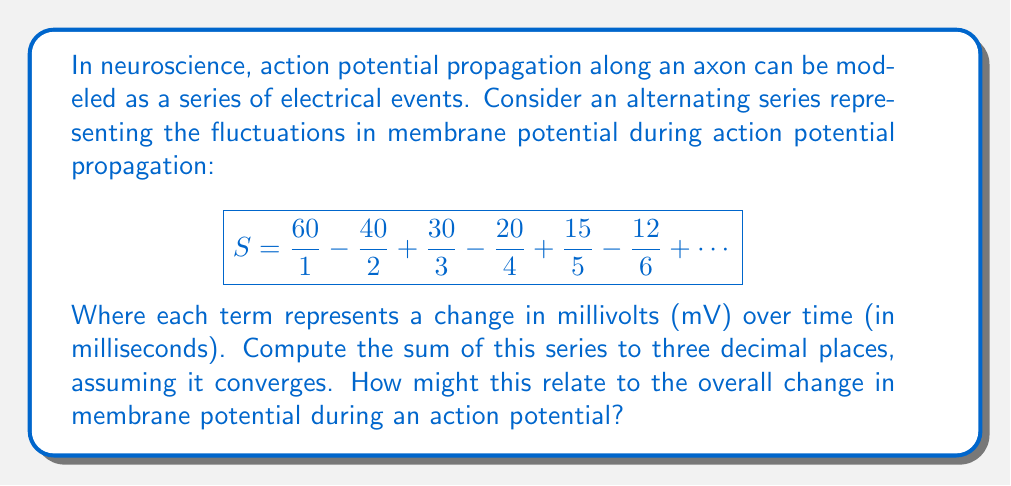What is the answer to this math problem? To solve this problem, we'll use the following approach:

1) First, we need to identify the pattern in the series. We can see that the numerators follow the sequence 60, 40, 30, 20, 15, 12, ..., and the denominators are simply the natural numbers 1, 2, 3, 4, 5, 6, ...

2) Let's try to express the general term of the series. For the nth term (where n is odd), we have:

   $$a_n = \frac{60}{n} \cdot \frac{2}{3}^{\frac{n-1}{2}}$$

   And for even n:

   $$a_n = -\frac{60}{n} \cdot \frac{2}{3}^{\frac{n-2}{2}}$$

3) This series is alternating, and we can prove that it converges using the alternating series test:
   - The absolute value of the terms decreases as n increases.
   - The limit of the absolute value of the terms as n approaches infinity is 0.

4) To compute the sum, we can use the alternating series estimation theorem. This states that for an alternating series, the error in stopping at any point is less than or equal to the absolute value of the next term.

5) Let's compute the partial sums until we reach the desired accuracy:

   $S_1 = 60$
   $S_2 = 60 - 20 = 40$
   $S_3 = 40 + 10 = 50$
   $S_4 = 50 - 5 = 45$
   $S_5 = 45 + 3 = 48$
   $S_6 = 48 - 2 = 46$
   $S_7 = 46 + 1.429 = 47.429$
   $S_8 = 47.429 - 0.938 = 46.491$

6) The next term would be less than 1 in absolute value, so we can stop here. Our answer to three decimal places is 46.491 mV.

Relating this to neuroscience: This sum could represent the net change in membrane potential during an action potential. The alternating nature of the series might model the rapid depolarization followed by repolarization and hyperpolarization phases of the action potential. The convergence to a finite sum could indicate that despite these fluctuations, the membrane potential ultimately stabilizes.
Answer: The sum of the series to three decimal places is 46.491 mV. 